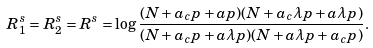<formula> <loc_0><loc_0><loc_500><loc_500>R _ { 1 } ^ { s } = R _ { 2 } ^ { s } = R ^ { s } = \log \frac { ( N + a _ { c } p + a p ) ( N + a _ { c } \lambda p + a \lambda p ) } { ( N + a _ { c } p + a \lambda p ) ( N + a \lambda p + a _ { c } p ) } .</formula> 